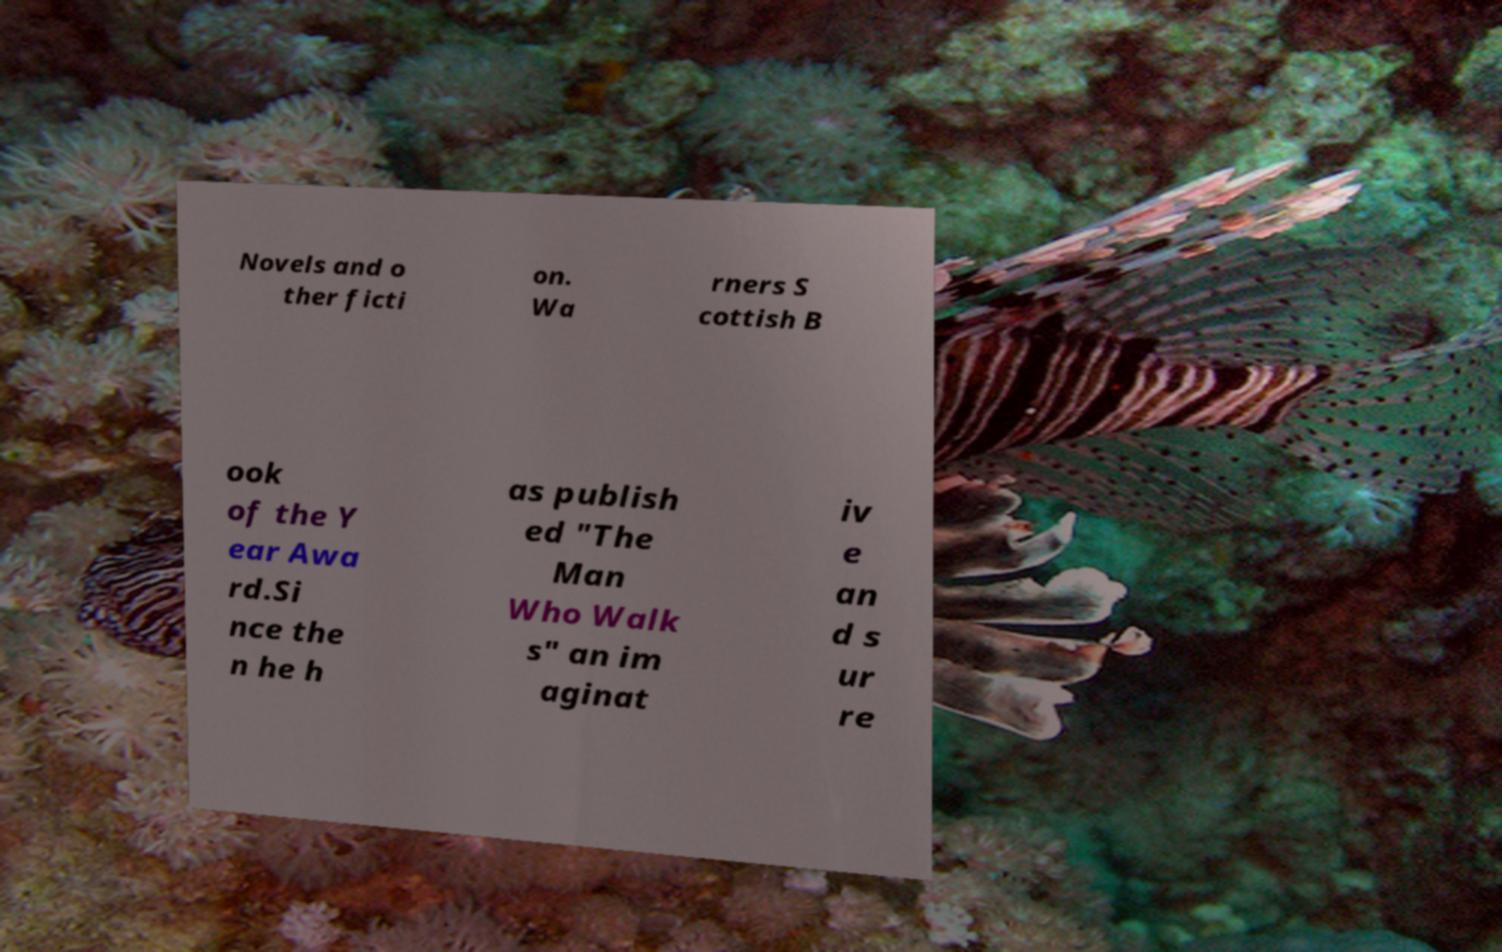Could you assist in decoding the text presented in this image and type it out clearly? Novels and o ther ficti on. Wa rners S cottish B ook of the Y ear Awa rd.Si nce the n he h as publish ed "The Man Who Walk s" an im aginat iv e an d s ur re 